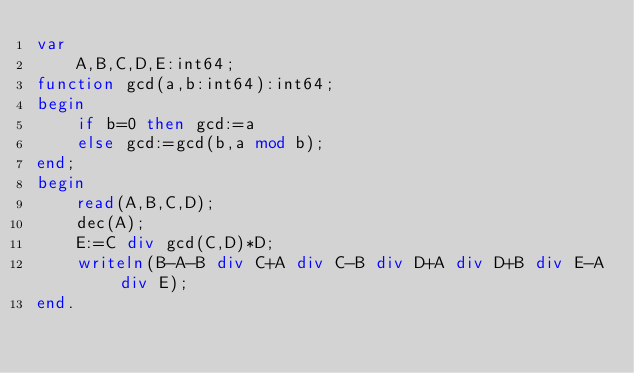<code> <loc_0><loc_0><loc_500><loc_500><_Pascal_>var
	A,B,C,D,E:int64;
function gcd(a,b:int64):int64;
begin
	if b=0 then gcd:=a
	else gcd:=gcd(b,a mod b);
end;
begin
	read(A,B,C,D);
	dec(A);
	E:=C div gcd(C,D)*D;
	writeln(B-A-B div C+A div C-B div D+A div D+B div E-A div E);
end.
</code> 